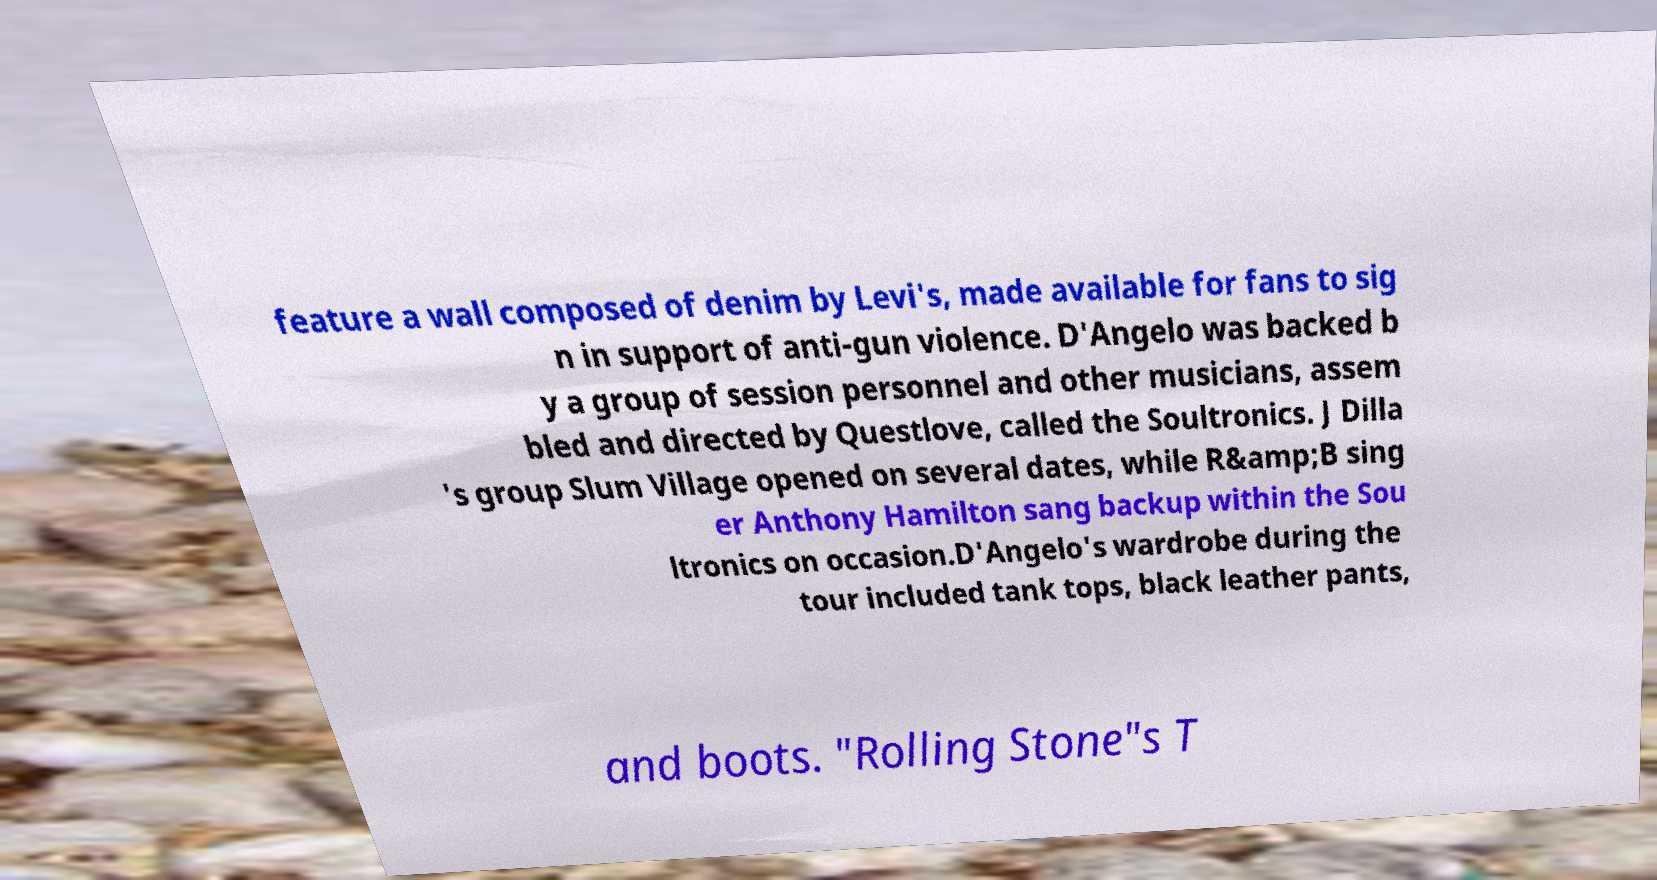What messages or text are displayed in this image? I need them in a readable, typed format. feature a wall composed of denim by Levi's, made available for fans to sig n in support of anti-gun violence. D'Angelo was backed b y a group of session personnel and other musicians, assem bled and directed by Questlove, called the Soultronics. J Dilla 's group Slum Village opened on several dates, while R&amp;B sing er Anthony Hamilton sang backup within the Sou ltronics on occasion.D'Angelo's wardrobe during the tour included tank tops, black leather pants, and boots. "Rolling Stone"s T 